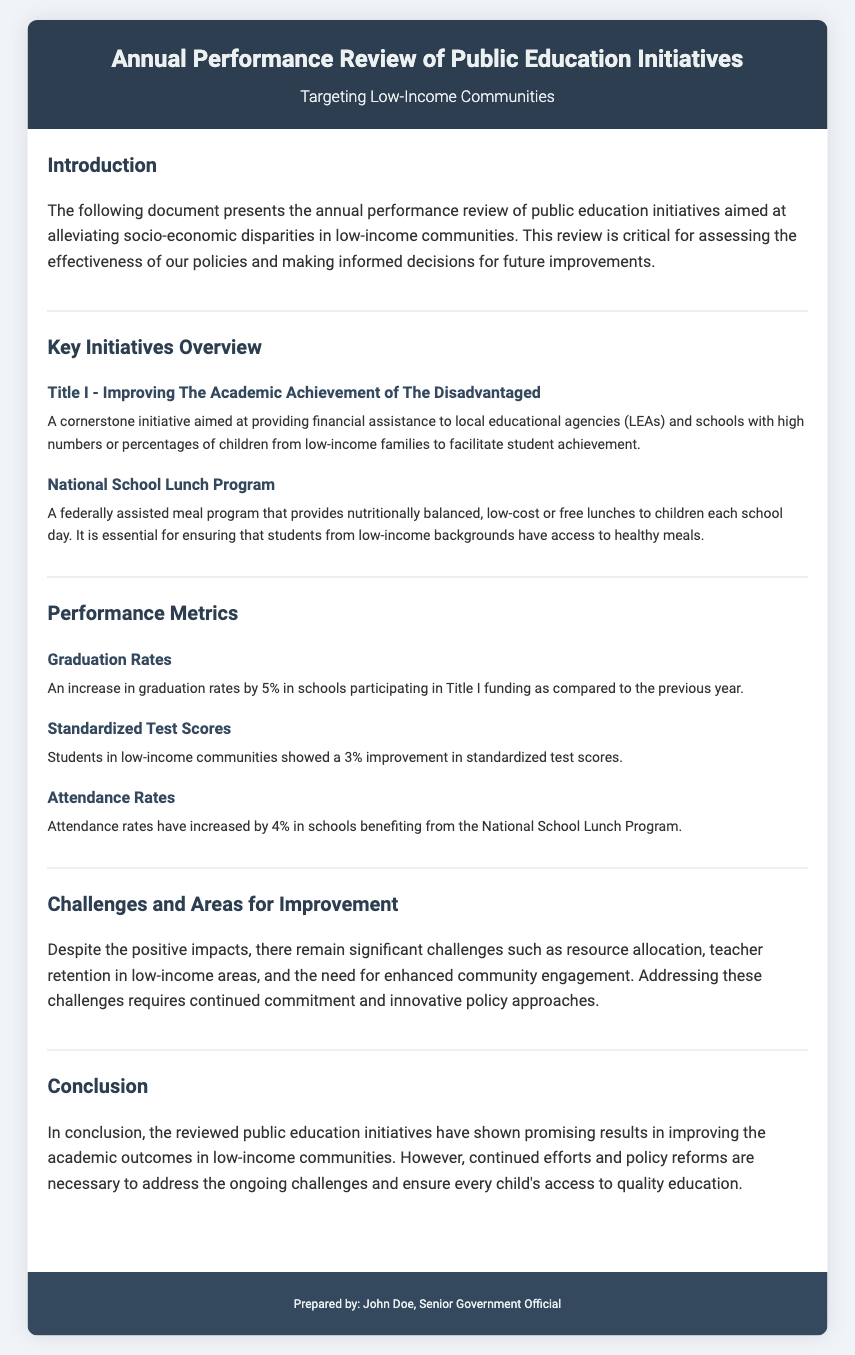What is the title of the document? The title of the document is prominently displayed in the header section.
Answer: Annual Performance Review of Public Education Initiatives What is the main focus of the initiatives? The introduction outlines that the initiatives are aimed at alleviating socio-economic disparities.
Answer: Socio-economic disparities What percentage did graduation rates increase by? The performance metrics section provides specific increases in graduation rates due to Title I funding.
Answer: 5% Which program provides low-cost or free lunches? The overview of key initiatives includes a specific program related to meal assistance for children.
Answer: National School Lunch Program What improvement was noted in standardized test scores? The performance metrics describe the improvement witnessed in standardized test scores among low-income students.
Answer: 3% What is one of the challenges mentioned in the review? The section on challenges indicates several areas that require improvement, and highlights significant issues.
Answer: Resource allocation Who prepared the document? The footer of the document identifies the author who prepared the review.
Answer: John Doe What type of funding does Title I provide? The description under the Title I initiative explains the type of financial support offered.
Answer: Financial assistance What was the increase in attendance rates associated with the National School Lunch Program? The performance metrics indicate specific increases in attendance due to this program.
Answer: 4% 